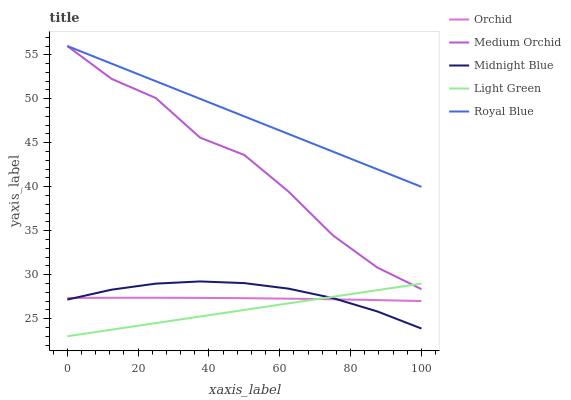Does Medium Orchid have the minimum area under the curve?
Answer yes or no. No. Does Medium Orchid have the maximum area under the curve?
Answer yes or no. No. Is Midnight Blue the smoothest?
Answer yes or no. No. Is Midnight Blue the roughest?
Answer yes or no. No. Does Medium Orchid have the lowest value?
Answer yes or no. No. Does Midnight Blue have the highest value?
Answer yes or no. No. Is Orchid less than Royal Blue?
Answer yes or no. Yes. Is Royal Blue greater than Light Green?
Answer yes or no. Yes. Does Orchid intersect Royal Blue?
Answer yes or no. No. 